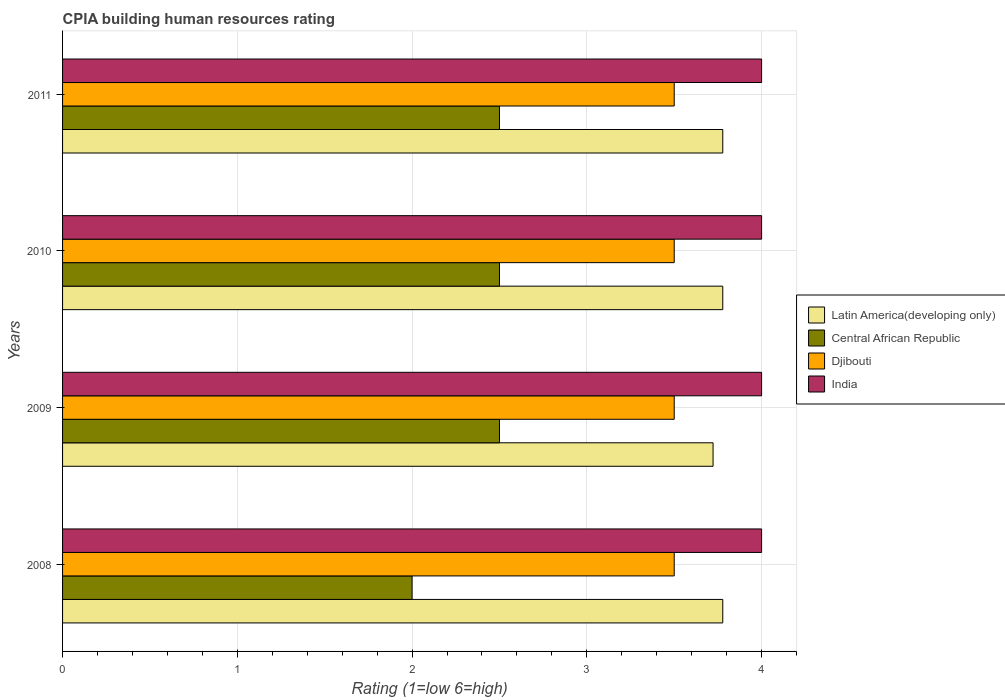How many different coloured bars are there?
Offer a very short reply. 4. How many groups of bars are there?
Your answer should be very brief. 4. Are the number of bars per tick equal to the number of legend labels?
Offer a terse response. Yes. Are the number of bars on each tick of the Y-axis equal?
Make the answer very short. Yes. How many bars are there on the 3rd tick from the top?
Offer a very short reply. 4. How many bars are there on the 4th tick from the bottom?
Keep it short and to the point. 4. What is the CPIA rating in Djibouti in 2010?
Your response must be concise. 3.5. Across all years, what is the maximum CPIA rating in India?
Give a very brief answer. 4. In which year was the CPIA rating in Central African Republic maximum?
Ensure brevity in your answer.  2009. What is the difference between the CPIA rating in Latin America(developing only) in 2010 and the CPIA rating in Djibouti in 2008?
Give a very brief answer. 0.28. What is the average CPIA rating in India per year?
Give a very brief answer. 4. In how many years, is the CPIA rating in India greater than 2.2 ?
Offer a terse response. 4. Is the CPIA rating in Latin America(developing only) in 2009 less than that in 2010?
Make the answer very short. Yes. What is the difference between the highest and the second highest CPIA rating in Djibouti?
Offer a terse response. 0. What is the difference between the highest and the lowest CPIA rating in Latin America(developing only)?
Your response must be concise. 0.06. In how many years, is the CPIA rating in Djibouti greater than the average CPIA rating in Djibouti taken over all years?
Offer a terse response. 0. What does the 1st bar from the top in 2008 represents?
Your response must be concise. India. What does the 1st bar from the bottom in 2011 represents?
Give a very brief answer. Latin America(developing only). Is it the case that in every year, the sum of the CPIA rating in Latin America(developing only) and CPIA rating in Djibouti is greater than the CPIA rating in India?
Offer a terse response. Yes. How many bars are there?
Provide a short and direct response. 16. Are all the bars in the graph horizontal?
Make the answer very short. Yes. How many years are there in the graph?
Your answer should be very brief. 4. What is the difference between two consecutive major ticks on the X-axis?
Your answer should be compact. 1. Are the values on the major ticks of X-axis written in scientific E-notation?
Keep it short and to the point. No. Does the graph contain any zero values?
Your answer should be compact. No. Where does the legend appear in the graph?
Your answer should be very brief. Center right. How many legend labels are there?
Your answer should be very brief. 4. What is the title of the graph?
Make the answer very short. CPIA building human resources rating. Does "Canada" appear as one of the legend labels in the graph?
Make the answer very short. No. What is the label or title of the X-axis?
Your answer should be compact. Rating (1=low 6=high). What is the Rating (1=low 6=high) in Latin America(developing only) in 2008?
Your answer should be compact. 3.78. What is the Rating (1=low 6=high) of Djibouti in 2008?
Ensure brevity in your answer.  3.5. What is the Rating (1=low 6=high) of Latin America(developing only) in 2009?
Make the answer very short. 3.72. What is the Rating (1=low 6=high) in Central African Republic in 2009?
Provide a succinct answer. 2.5. What is the Rating (1=low 6=high) of Djibouti in 2009?
Give a very brief answer. 3.5. What is the Rating (1=low 6=high) of Latin America(developing only) in 2010?
Ensure brevity in your answer.  3.78. What is the Rating (1=low 6=high) in Central African Republic in 2010?
Provide a succinct answer. 2.5. What is the Rating (1=low 6=high) of India in 2010?
Offer a very short reply. 4. What is the Rating (1=low 6=high) of Latin America(developing only) in 2011?
Make the answer very short. 3.78. What is the Rating (1=low 6=high) of Djibouti in 2011?
Give a very brief answer. 3.5. Across all years, what is the maximum Rating (1=low 6=high) of Latin America(developing only)?
Make the answer very short. 3.78. Across all years, what is the minimum Rating (1=low 6=high) of Latin America(developing only)?
Your response must be concise. 3.72. Across all years, what is the minimum Rating (1=low 6=high) of Central African Republic?
Your response must be concise. 2. What is the total Rating (1=low 6=high) of Latin America(developing only) in the graph?
Your response must be concise. 15.06. What is the difference between the Rating (1=low 6=high) in Latin America(developing only) in 2008 and that in 2009?
Provide a short and direct response. 0.06. What is the difference between the Rating (1=low 6=high) in Central African Republic in 2008 and that in 2009?
Your answer should be very brief. -0.5. What is the difference between the Rating (1=low 6=high) in India in 2008 and that in 2010?
Your answer should be very brief. 0. What is the difference between the Rating (1=low 6=high) in Central African Republic in 2008 and that in 2011?
Make the answer very short. -0.5. What is the difference between the Rating (1=low 6=high) in Latin America(developing only) in 2009 and that in 2010?
Keep it short and to the point. -0.06. What is the difference between the Rating (1=low 6=high) in India in 2009 and that in 2010?
Keep it short and to the point. 0. What is the difference between the Rating (1=low 6=high) of Latin America(developing only) in 2009 and that in 2011?
Your response must be concise. -0.06. What is the difference between the Rating (1=low 6=high) in Central African Republic in 2009 and that in 2011?
Your answer should be compact. 0. What is the difference between the Rating (1=low 6=high) in India in 2009 and that in 2011?
Your response must be concise. 0. What is the difference between the Rating (1=low 6=high) in Latin America(developing only) in 2010 and that in 2011?
Ensure brevity in your answer.  0. What is the difference between the Rating (1=low 6=high) in Central African Republic in 2010 and that in 2011?
Provide a succinct answer. 0. What is the difference between the Rating (1=low 6=high) of India in 2010 and that in 2011?
Provide a succinct answer. 0. What is the difference between the Rating (1=low 6=high) in Latin America(developing only) in 2008 and the Rating (1=low 6=high) in Central African Republic in 2009?
Offer a terse response. 1.28. What is the difference between the Rating (1=low 6=high) in Latin America(developing only) in 2008 and the Rating (1=low 6=high) in Djibouti in 2009?
Keep it short and to the point. 0.28. What is the difference between the Rating (1=low 6=high) in Latin America(developing only) in 2008 and the Rating (1=low 6=high) in India in 2009?
Provide a succinct answer. -0.22. What is the difference between the Rating (1=low 6=high) in Central African Republic in 2008 and the Rating (1=low 6=high) in Djibouti in 2009?
Your response must be concise. -1.5. What is the difference between the Rating (1=low 6=high) of Djibouti in 2008 and the Rating (1=low 6=high) of India in 2009?
Your answer should be compact. -0.5. What is the difference between the Rating (1=low 6=high) in Latin America(developing only) in 2008 and the Rating (1=low 6=high) in Central African Republic in 2010?
Offer a very short reply. 1.28. What is the difference between the Rating (1=low 6=high) in Latin America(developing only) in 2008 and the Rating (1=low 6=high) in Djibouti in 2010?
Ensure brevity in your answer.  0.28. What is the difference between the Rating (1=low 6=high) of Latin America(developing only) in 2008 and the Rating (1=low 6=high) of India in 2010?
Ensure brevity in your answer.  -0.22. What is the difference between the Rating (1=low 6=high) in Latin America(developing only) in 2008 and the Rating (1=low 6=high) in Central African Republic in 2011?
Offer a very short reply. 1.28. What is the difference between the Rating (1=low 6=high) of Latin America(developing only) in 2008 and the Rating (1=low 6=high) of Djibouti in 2011?
Your answer should be compact. 0.28. What is the difference between the Rating (1=low 6=high) in Latin America(developing only) in 2008 and the Rating (1=low 6=high) in India in 2011?
Provide a short and direct response. -0.22. What is the difference between the Rating (1=low 6=high) of Central African Republic in 2008 and the Rating (1=low 6=high) of Djibouti in 2011?
Offer a terse response. -1.5. What is the difference between the Rating (1=low 6=high) of Djibouti in 2008 and the Rating (1=low 6=high) of India in 2011?
Keep it short and to the point. -0.5. What is the difference between the Rating (1=low 6=high) of Latin America(developing only) in 2009 and the Rating (1=low 6=high) of Central African Republic in 2010?
Your answer should be very brief. 1.22. What is the difference between the Rating (1=low 6=high) in Latin America(developing only) in 2009 and the Rating (1=low 6=high) in Djibouti in 2010?
Keep it short and to the point. 0.22. What is the difference between the Rating (1=low 6=high) in Latin America(developing only) in 2009 and the Rating (1=low 6=high) in India in 2010?
Ensure brevity in your answer.  -0.28. What is the difference between the Rating (1=low 6=high) of Central African Republic in 2009 and the Rating (1=low 6=high) of Djibouti in 2010?
Your answer should be compact. -1. What is the difference between the Rating (1=low 6=high) in Central African Republic in 2009 and the Rating (1=low 6=high) in India in 2010?
Your answer should be compact. -1.5. What is the difference between the Rating (1=low 6=high) of Latin America(developing only) in 2009 and the Rating (1=low 6=high) of Central African Republic in 2011?
Provide a succinct answer. 1.22. What is the difference between the Rating (1=low 6=high) in Latin America(developing only) in 2009 and the Rating (1=low 6=high) in Djibouti in 2011?
Offer a terse response. 0.22. What is the difference between the Rating (1=low 6=high) of Latin America(developing only) in 2009 and the Rating (1=low 6=high) of India in 2011?
Offer a terse response. -0.28. What is the difference between the Rating (1=low 6=high) in Central African Republic in 2009 and the Rating (1=low 6=high) in Djibouti in 2011?
Make the answer very short. -1. What is the difference between the Rating (1=low 6=high) of Latin America(developing only) in 2010 and the Rating (1=low 6=high) of Central African Republic in 2011?
Ensure brevity in your answer.  1.28. What is the difference between the Rating (1=low 6=high) of Latin America(developing only) in 2010 and the Rating (1=low 6=high) of Djibouti in 2011?
Your answer should be compact. 0.28. What is the difference between the Rating (1=low 6=high) of Latin America(developing only) in 2010 and the Rating (1=low 6=high) of India in 2011?
Ensure brevity in your answer.  -0.22. What is the difference between the Rating (1=low 6=high) of Central African Republic in 2010 and the Rating (1=low 6=high) of India in 2011?
Your response must be concise. -1.5. What is the difference between the Rating (1=low 6=high) of Djibouti in 2010 and the Rating (1=low 6=high) of India in 2011?
Give a very brief answer. -0.5. What is the average Rating (1=low 6=high) in Latin America(developing only) per year?
Give a very brief answer. 3.76. What is the average Rating (1=low 6=high) of Central African Republic per year?
Keep it short and to the point. 2.38. What is the average Rating (1=low 6=high) of Djibouti per year?
Your answer should be compact. 3.5. In the year 2008, what is the difference between the Rating (1=low 6=high) in Latin America(developing only) and Rating (1=low 6=high) in Central African Republic?
Make the answer very short. 1.78. In the year 2008, what is the difference between the Rating (1=low 6=high) in Latin America(developing only) and Rating (1=low 6=high) in Djibouti?
Make the answer very short. 0.28. In the year 2008, what is the difference between the Rating (1=low 6=high) of Latin America(developing only) and Rating (1=low 6=high) of India?
Your response must be concise. -0.22. In the year 2008, what is the difference between the Rating (1=low 6=high) in Central African Republic and Rating (1=low 6=high) in India?
Your response must be concise. -2. In the year 2009, what is the difference between the Rating (1=low 6=high) of Latin America(developing only) and Rating (1=low 6=high) of Central African Republic?
Provide a short and direct response. 1.22. In the year 2009, what is the difference between the Rating (1=low 6=high) in Latin America(developing only) and Rating (1=low 6=high) in Djibouti?
Your answer should be compact. 0.22. In the year 2009, what is the difference between the Rating (1=low 6=high) in Latin America(developing only) and Rating (1=low 6=high) in India?
Keep it short and to the point. -0.28. In the year 2009, what is the difference between the Rating (1=low 6=high) of Central African Republic and Rating (1=low 6=high) of India?
Provide a succinct answer. -1.5. In the year 2010, what is the difference between the Rating (1=low 6=high) of Latin America(developing only) and Rating (1=low 6=high) of Central African Republic?
Provide a short and direct response. 1.28. In the year 2010, what is the difference between the Rating (1=low 6=high) in Latin America(developing only) and Rating (1=low 6=high) in Djibouti?
Ensure brevity in your answer.  0.28. In the year 2010, what is the difference between the Rating (1=low 6=high) of Latin America(developing only) and Rating (1=low 6=high) of India?
Offer a terse response. -0.22. In the year 2010, what is the difference between the Rating (1=low 6=high) of Central African Republic and Rating (1=low 6=high) of Djibouti?
Provide a succinct answer. -1. In the year 2011, what is the difference between the Rating (1=low 6=high) in Latin America(developing only) and Rating (1=low 6=high) in Central African Republic?
Provide a short and direct response. 1.28. In the year 2011, what is the difference between the Rating (1=low 6=high) in Latin America(developing only) and Rating (1=low 6=high) in Djibouti?
Provide a succinct answer. 0.28. In the year 2011, what is the difference between the Rating (1=low 6=high) in Latin America(developing only) and Rating (1=low 6=high) in India?
Provide a short and direct response. -0.22. What is the ratio of the Rating (1=low 6=high) in Latin America(developing only) in 2008 to that in 2009?
Provide a succinct answer. 1.01. What is the ratio of the Rating (1=low 6=high) of Djibouti in 2008 to that in 2009?
Your answer should be very brief. 1. What is the ratio of the Rating (1=low 6=high) of Central African Republic in 2008 to that in 2010?
Make the answer very short. 0.8. What is the ratio of the Rating (1=low 6=high) in Djibouti in 2008 to that in 2010?
Offer a terse response. 1. What is the ratio of the Rating (1=low 6=high) in Latin America(developing only) in 2008 to that in 2011?
Provide a succinct answer. 1. What is the ratio of the Rating (1=low 6=high) in Central African Republic in 2009 to that in 2011?
Provide a short and direct response. 1. What is the ratio of the Rating (1=low 6=high) in Latin America(developing only) in 2010 to that in 2011?
Keep it short and to the point. 1. What is the ratio of the Rating (1=low 6=high) of Djibouti in 2010 to that in 2011?
Make the answer very short. 1. What is the ratio of the Rating (1=low 6=high) in India in 2010 to that in 2011?
Give a very brief answer. 1. What is the difference between the highest and the second highest Rating (1=low 6=high) of Djibouti?
Keep it short and to the point. 0. What is the difference between the highest and the second highest Rating (1=low 6=high) of India?
Provide a succinct answer. 0. What is the difference between the highest and the lowest Rating (1=low 6=high) in Latin America(developing only)?
Make the answer very short. 0.06. What is the difference between the highest and the lowest Rating (1=low 6=high) of India?
Ensure brevity in your answer.  0. 